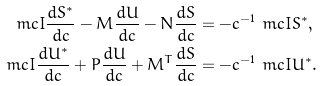Convert formula to latex. <formula><loc_0><loc_0><loc_500><loc_500>\ m c { I } \frac { d S ^ { \ast } } { d c } - M \frac { d U } { d c } - N \frac { d S } { d c } & = - c ^ { - 1 } \ m c { I } S ^ { \ast } , \\ \ m c { I } \frac { d U ^ { \ast } } { d c } + P \frac { d U } { d c } + M ^ { T } \frac { d S } { d c } & = - c ^ { - 1 } \ m c { I } U ^ { \ast } .</formula> 